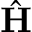<formula> <loc_0><loc_0><loc_500><loc_500>\hat { H }</formula> 